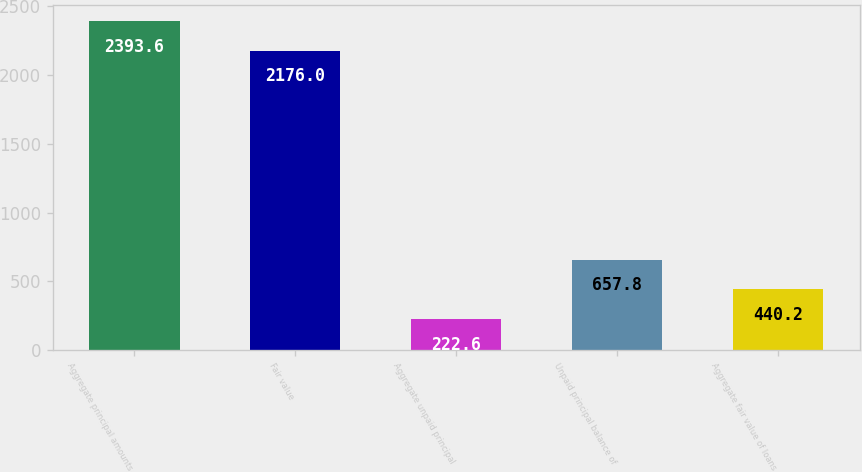Convert chart. <chart><loc_0><loc_0><loc_500><loc_500><bar_chart><fcel>Aggregate principal amounts<fcel>Fair value<fcel>Aggregate unpaid principal<fcel>Unpaid principal balance of<fcel>Aggregate fair value of loans<nl><fcel>2393.6<fcel>2176<fcel>222.6<fcel>657.8<fcel>440.2<nl></chart> 